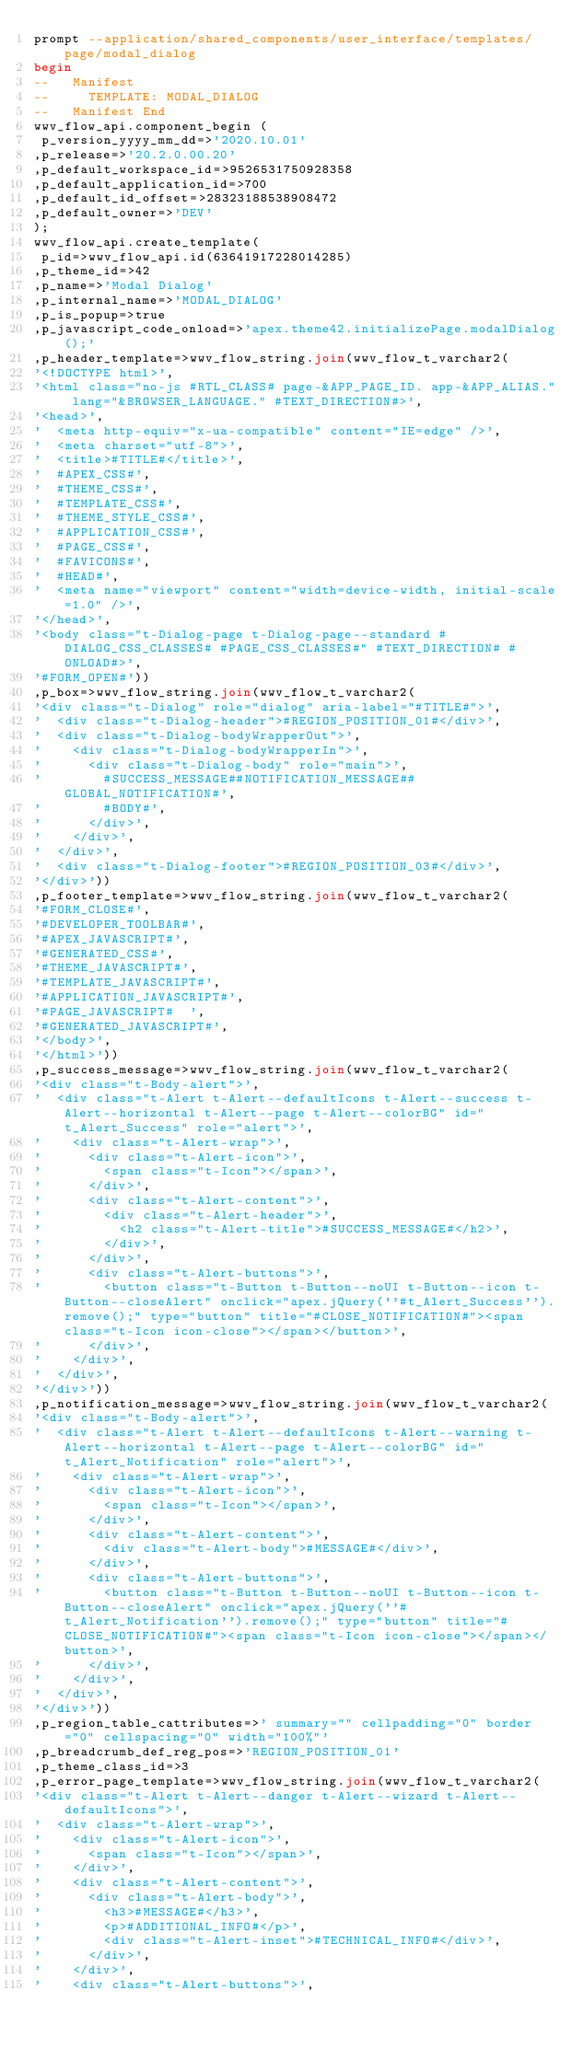Convert code to text. <code><loc_0><loc_0><loc_500><loc_500><_SQL_>prompt --application/shared_components/user_interface/templates/page/modal_dialog
begin
--   Manifest
--     TEMPLATE: MODAL_DIALOG
--   Manifest End
wwv_flow_api.component_begin (
 p_version_yyyy_mm_dd=>'2020.10.01'
,p_release=>'20.2.0.00.20'
,p_default_workspace_id=>9526531750928358
,p_default_application_id=>700
,p_default_id_offset=>28323188538908472
,p_default_owner=>'DEV'
);
wwv_flow_api.create_template(
 p_id=>wwv_flow_api.id(63641917228014285)
,p_theme_id=>42
,p_name=>'Modal Dialog'
,p_internal_name=>'MODAL_DIALOG'
,p_is_popup=>true
,p_javascript_code_onload=>'apex.theme42.initializePage.modalDialog();'
,p_header_template=>wwv_flow_string.join(wwv_flow_t_varchar2(
'<!DOCTYPE html>',
'<html class="no-js #RTL_CLASS# page-&APP_PAGE_ID. app-&APP_ALIAS." lang="&BROWSER_LANGUAGE." #TEXT_DIRECTION#>',
'<head>',
'  <meta http-equiv="x-ua-compatible" content="IE=edge" />',
'  <meta charset="utf-8">',
'  <title>#TITLE#</title>',
'  #APEX_CSS#',
'  #THEME_CSS#',
'  #TEMPLATE_CSS#',
'  #THEME_STYLE_CSS#',
'  #APPLICATION_CSS#',
'  #PAGE_CSS#',
'  #FAVICONS#',
'  #HEAD#',
'  <meta name="viewport" content="width=device-width, initial-scale=1.0" />',
'</head>',
'<body class="t-Dialog-page t-Dialog-page--standard #DIALOG_CSS_CLASSES# #PAGE_CSS_CLASSES#" #TEXT_DIRECTION# #ONLOAD#>',
'#FORM_OPEN#'))
,p_box=>wwv_flow_string.join(wwv_flow_t_varchar2(
'<div class="t-Dialog" role="dialog" aria-label="#TITLE#">',
'  <div class="t-Dialog-header">#REGION_POSITION_01#</div>',
'  <div class="t-Dialog-bodyWrapperOut">',
'    <div class="t-Dialog-bodyWrapperIn">',
'      <div class="t-Dialog-body" role="main">',
'        #SUCCESS_MESSAGE##NOTIFICATION_MESSAGE##GLOBAL_NOTIFICATION#',
'        #BODY#',
'      </div>',
'    </div>',
'  </div>',
'  <div class="t-Dialog-footer">#REGION_POSITION_03#</div>',
'</div>'))
,p_footer_template=>wwv_flow_string.join(wwv_flow_t_varchar2(
'#FORM_CLOSE#',
'#DEVELOPER_TOOLBAR#',
'#APEX_JAVASCRIPT#',
'#GENERATED_CSS#',
'#THEME_JAVASCRIPT#',
'#TEMPLATE_JAVASCRIPT#',
'#APPLICATION_JAVASCRIPT#',
'#PAGE_JAVASCRIPT#  ',
'#GENERATED_JAVASCRIPT#',
'</body>',
'</html>'))
,p_success_message=>wwv_flow_string.join(wwv_flow_t_varchar2(
'<div class="t-Body-alert">',
'  <div class="t-Alert t-Alert--defaultIcons t-Alert--success t-Alert--horizontal t-Alert--page t-Alert--colorBG" id="t_Alert_Success" role="alert">',
'    <div class="t-Alert-wrap">',
'      <div class="t-Alert-icon">',
'        <span class="t-Icon"></span>',
'      </div>',
'      <div class="t-Alert-content">',
'        <div class="t-Alert-header">',
'          <h2 class="t-Alert-title">#SUCCESS_MESSAGE#</h2>',
'        </div>',
'      </div>',
'      <div class="t-Alert-buttons">',
'        <button class="t-Button t-Button--noUI t-Button--icon t-Button--closeAlert" onclick="apex.jQuery(''#t_Alert_Success'').remove();" type="button" title="#CLOSE_NOTIFICATION#"><span class="t-Icon icon-close"></span></button>',
'      </div>',
'    </div>',
'  </div>',
'</div>'))
,p_notification_message=>wwv_flow_string.join(wwv_flow_t_varchar2(
'<div class="t-Body-alert">',
'  <div class="t-Alert t-Alert--defaultIcons t-Alert--warning t-Alert--horizontal t-Alert--page t-Alert--colorBG" id="t_Alert_Notification" role="alert">',
'    <div class="t-Alert-wrap">',
'      <div class="t-Alert-icon">',
'        <span class="t-Icon"></span>',
'      </div>',
'      <div class="t-Alert-content">',
'        <div class="t-Alert-body">#MESSAGE#</div>',
'      </div>',
'      <div class="t-Alert-buttons">',
'        <button class="t-Button t-Button--noUI t-Button--icon t-Button--closeAlert" onclick="apex.jQuery(''#t_Alert_Notification'').remove();" type="button" title="#CLOSE_NOTIFICATION#"><span class="t-Icon icon-close"></span></button>',
'      </div>',
'    </div>',
'  </div>',
'</div>'))
,p_region_table_cattributes=>' summary="" cellpadding="0" border="0" cellspacing="0" width="100%"'
,p_breadcrumb_def_reg_pos=>'REGION_POSITION_01'
,p_theme_class_id=>3
,p_error_page_template=>wwv_flow_string.join(wwv_flow_t_varchar2(
'<div class="t-Alert t-Alert--danger t-Alert--wizard t-Alert--defaultIcons">',
'  <div class="t-Alert-wrap">',
'    <div class="t-Alert-icon">',
'      <span class="t-Icon"></span>',
'    </div>',
'    <div class="t-Alert-content">',
'      <div class="t-Alert-body">',
'        <h3>#MESSAGE#</h3>',
'        <p>#ADDITIONAL_INFO#</p>',
'        <div class="t-Alert-inset">#TECHNICAL_INFO#</div>',
'      </div>',
'    </div>',
'    <div class="t-Alert-buttons">',</code> 